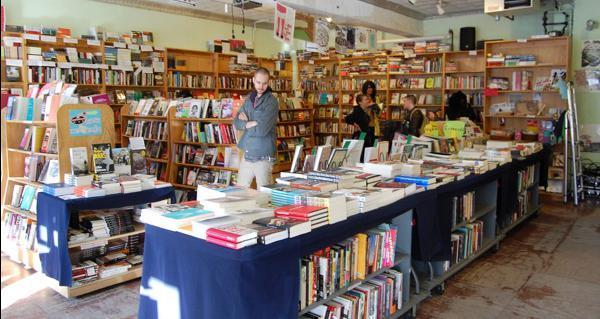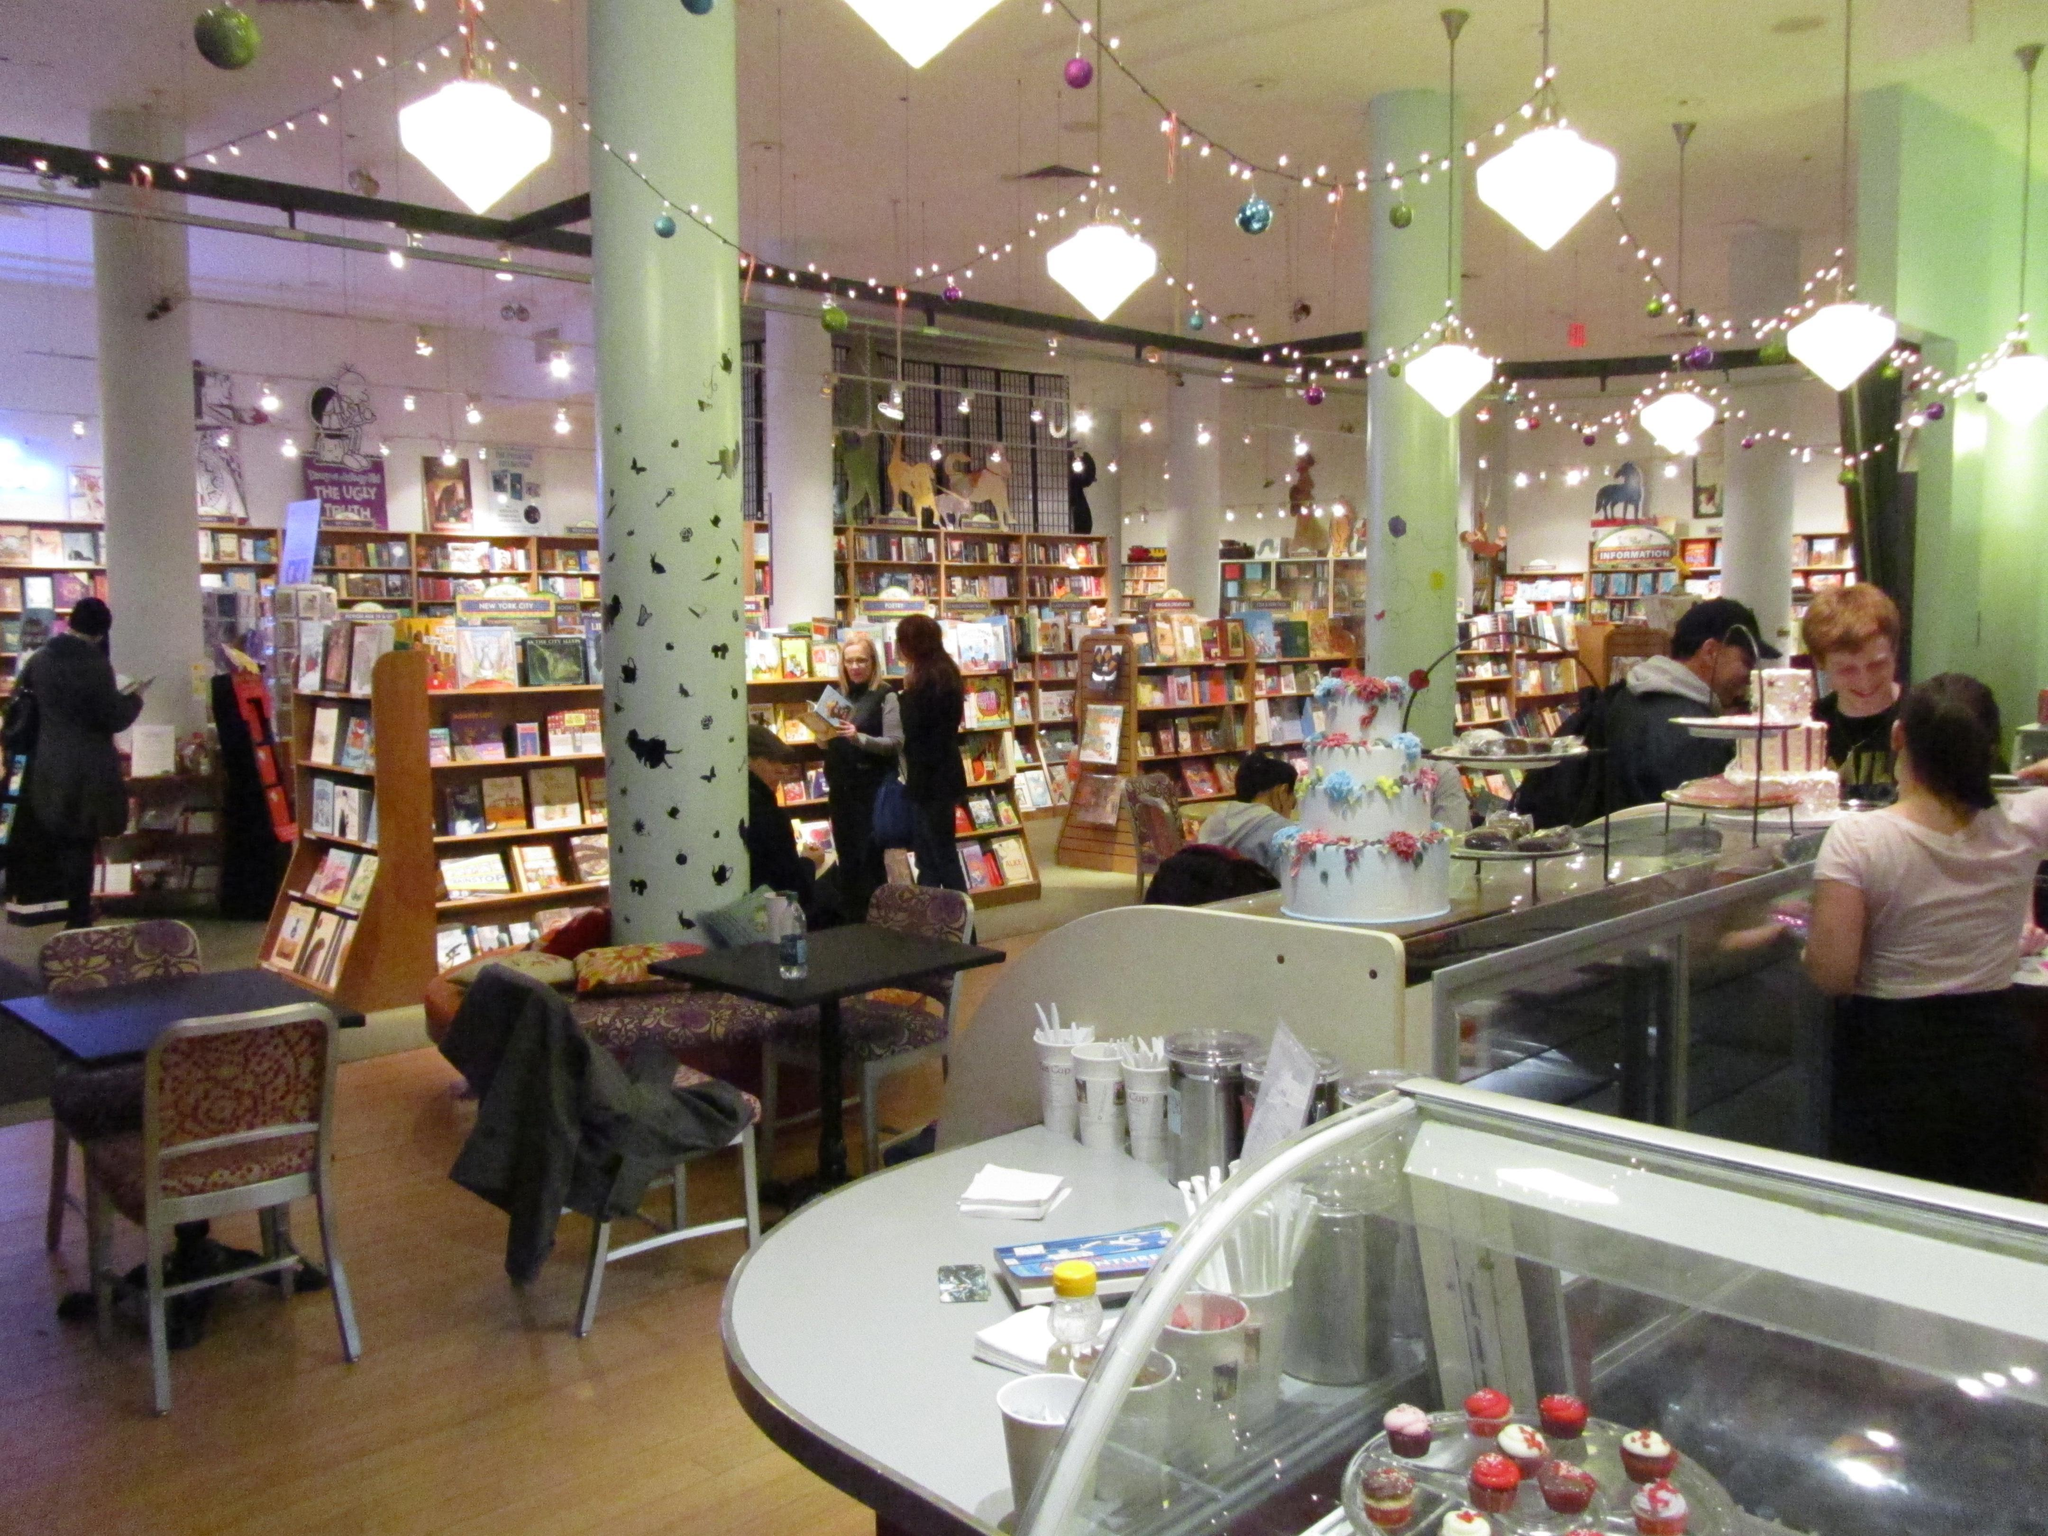The first image is the image on the left, the second image is the image on the right. For the images shown, is this caption "There are banks of fluorescent lights visible in at least one of the images." true? Answer yes or no. No. The first image is the image on the left, the second image is the image on the right. Given the left and right images, does the statement "The right image shows a bookstore interior with T-shaped wooden support beams in front of a green wall and behind freestanding displays of books." hold true? Answer yes or no. No. 